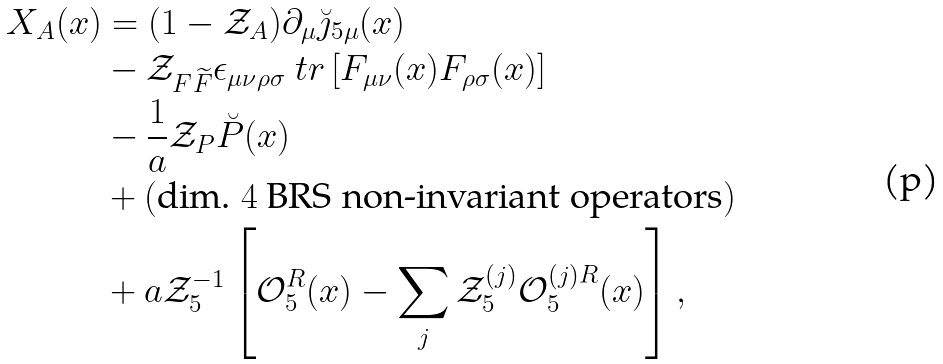<formula> <loc_0><loc_0><loc_500><loc_500>X _ { A } ( x ) & = ( 1 - \mathcal { Z } _ { A } ) \partial _ { \mu } \breve { \jmath } _ { 5 \mu } ( x ) \\ & - \mathcal { Z } _ { F \widetilde { F } } \epsilon _ { \mu \nu \rho \sigma } \ t r \left [ F _ { \mu \nu } ( x ) F _ { \rho \sigma } ( x ) \right ] \\ & - \frac { 1 } { a } \mathcal { Z } _ { P } \breve { P } ( x ) \\ & + ( \text {dim.\ $4$ BRS non-invariant operators} ) \\ & + a \mathcal { Z } _ { 5 } ^ { - 1 } \left [ \mathcal { O } _ { 5 } ^ { R } ( x ) - \sum _ { j } \mathcal { Z } _ { 5 } ^ { ( j ) } \mathcal { O } _ { 5 } ^ { ( j ) R } ( x ) \right ] ,</formula> 